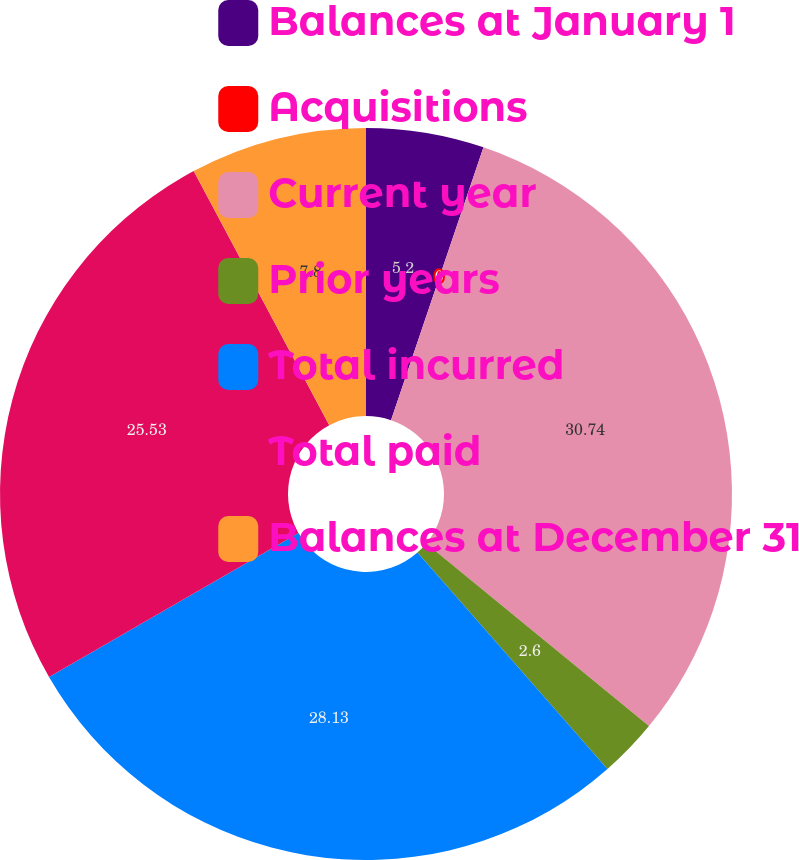Convert chart to OTSL. <chart><loc_0><loc_0><loc_500><loc_500><pie_chart><fcel>Balances at January 1<fcel>Acquisitions<fcel>Current year<fcel>Prior years<fcel>Total incurred<fcel>Total paid<fcel>Balances at December 31<nl><fcel>5.2%<fcel>0.0%<fcel>30.73%<fcel>2.6%<fcel>28.13%<fcel>25.53%<fcel>7.8%<nl></chart> 